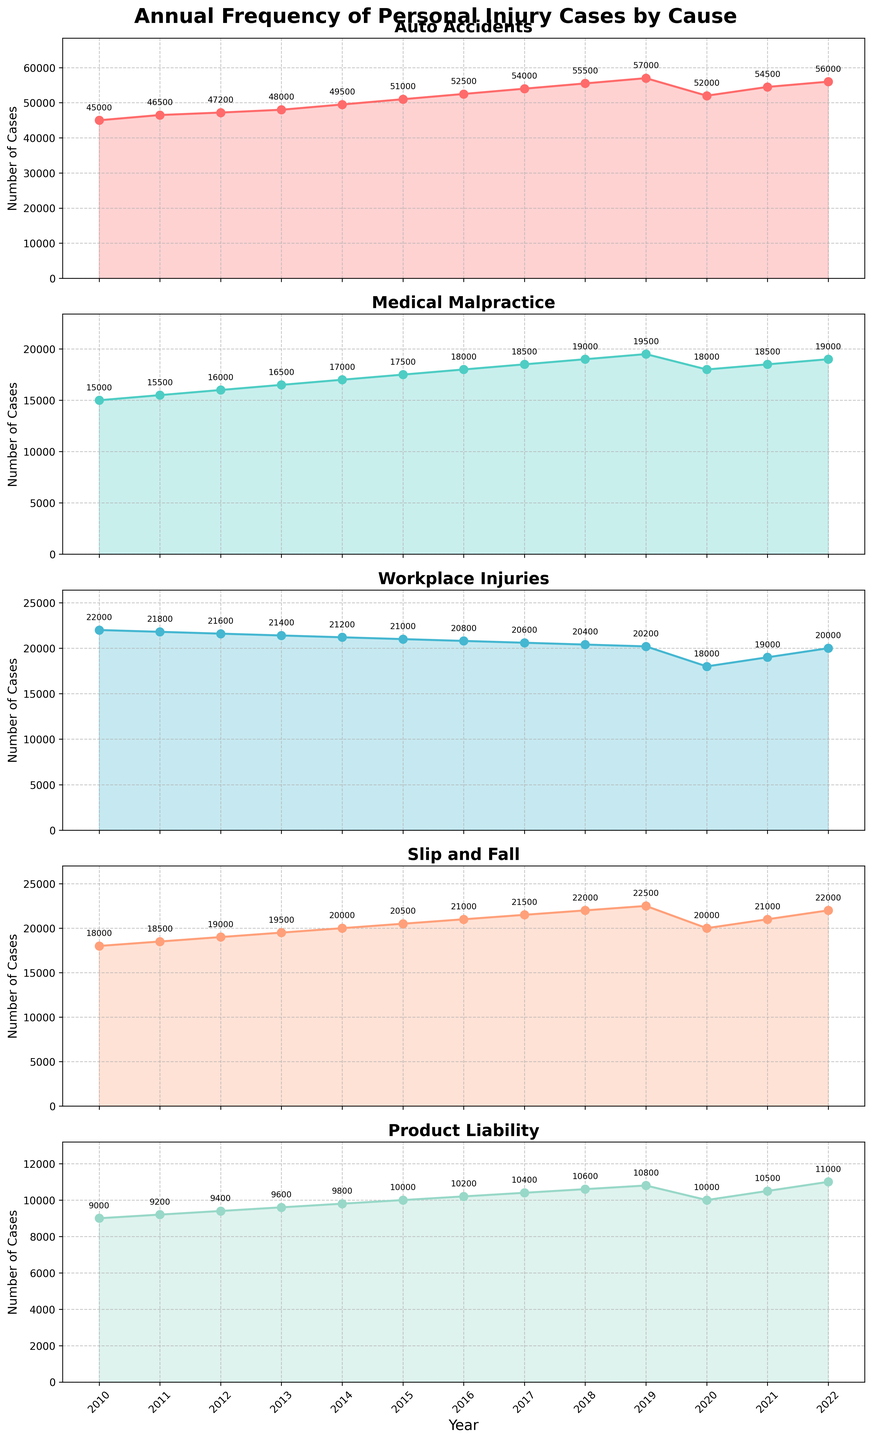What's the difference in the number of Auto Accidents cases filed between 2019 and 2020? In 2019, the number of Auto Accidents cases was 57,000, and in 2020 it was 52,000. The difference is 57,000 - 52,000 = 5,000.
Answer: 5,000 Which cause of personal injury cases had the highest number of cases in any single year, and in which year did this occur? By examining all the subplots, we see that Auto Accidents in 2020 had the highest number with 57,000 cases.
Answer: Auto Accidents, 2019 Across the entire period, which cause of personal injury cases shows the most consistent annual increase? From the subplots, Auto Accidents cases show a consistent annual increase from 2010 to 2019, except for a small dip in 2020. Other causes either show more variability or do not consistently increase.
Answer: Auto Accidents What is the average number of Medical Malpractice cases filed per year between 2010 and 2022? Summing up the annual cases: 15,000 + 15,500 + 16,000 + 16,500 + 17,000 + 17,500 + 18,000 + 18,500 + 19,000 + 19,500 + 18,000 + 18,500 + 19,000 = 221,000. Dividing by 13 years: 221,000 / 13 ≈ 17,000.
Answer: ~17,000 How many years show a decrease in Workplace Injuries compared to the previous year? By analyzing the Workplace Injuries subplot, decreases are noted in these intervals: 2011 to 2012, 2012 to 2013, 2013 to 2014, 2014 to 2015, 2015 to 2016, and 2017 to 2018.
Answer: 6 years Which two causes of personal injury cases appear to be the least and most volatile over the observed years? From the chart, Auto Accidents had the most consistent trend while Product Liability exhibits a more gradual and consistent increase or decrease, appearing less volatile.
Answer: Most volatile: Auto Accidents, Least: Product Liability In what year did Slip and Fall cases first surpass 20,000? By examining the subplot for Slip and Fall, we see that it first surpassed 20,000 cases in 2017.
Answer: 2017 